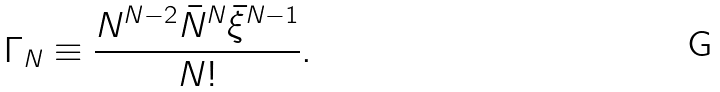Convert formula to latex. <formula><loc_0><loc_0><loc_500><loc_500>\Gamma _ { N } \equiv \frac { N ^ { N - 2 } { \bar { N } } ^ { N } { \bar { \xi } } ^ { N - 1 } } { N ! } .</formula> 